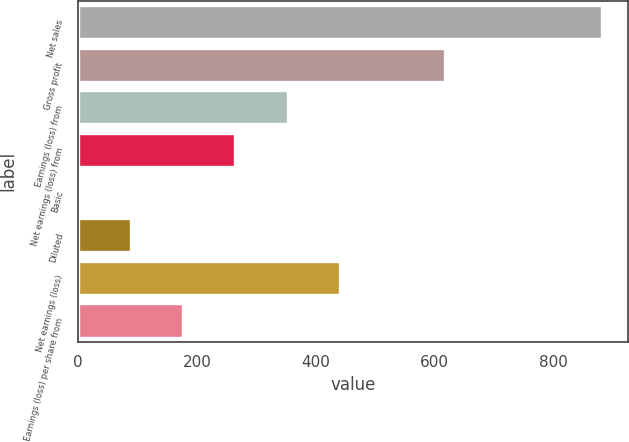Convert chart. <chart><loc_0><loc_0><loc_500><loc_500><bar_chart><fcel>Net sales<fcel>Gross profit<fcel>Earnings (loss) from<fcel>Net earnings (loss) from<fcel>Basic<fcel>Diluted<fcel>Net earnings (loss)<fcel>Earnings (loss) per share from<nl><fcel>882.5<fcel>617.79<fcel>353.05<fcel>264.8<fcel>0.05<fcel>88.3<fcel>441.3<fcel>176.55<nl></chart> 